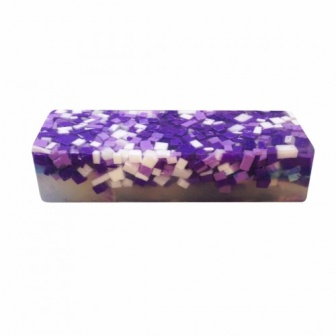Imagine this bar of soap is part of a special collection. What might be the theme of this collection? The bar of soap could be part of a special 'Mosaic Dreams' collection. This theme emphasizes artistic self-expression and relaxation through bath and body products. Each soap in the collection can represent different moods and times of day, such as 'Twilight Serenity' with deeper purples and 'Morning Blossoms' with lighter lavender tones. This collection can transform a mundane bath routine into a relaxing, luxurious experience, allowing users to indulge in art and relaxation. 